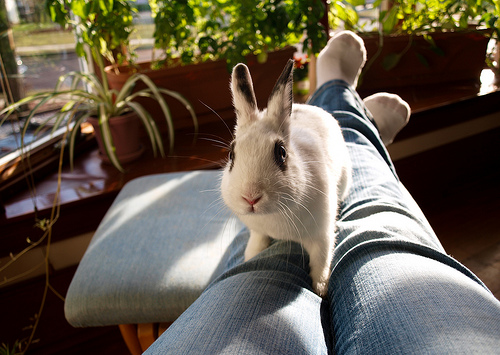<image>
Is there a rabbit on the person? Yes. Looking at the image, I can see the rabbit is positioned on top of the person, with the person providing support. 